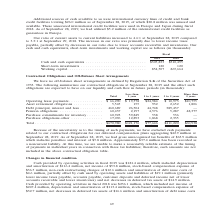According to Coherent's financial document, Where were the unsecured international credit facilities used in? Europe and Japan during fiscal 2018. The document states: "ured international credit facilities were used in Europe and Japan during fiscal 2018. As of September 28, 2019, we had utilized $5.2 million of the i..." Also, What led to the increase in the ratio of current assets to current liabilities? primarily due to lower income taxes payable, partially offset by decreases in our ratio due to lower accounts receivable and inventories.. The document states: "September 29, 2018. The increase in our ratio was primarily due to lower income taxes payable, partially offset by decreases in our ratio due to lower..." Also, In which years was information on cash and cash equivalents, short-term investments and working capital provided? The document shows two values: 2019 and 2018. From the document: "Fiscal 2019 2018 Fiscal 2019 2018..." Additionally, In which year was Cash and cash equivalents larger? According to the financial document, 2018. The relevant text states: "Fiscal 2019 2018..." Also, can you calculate: What was the change in Short-term investments in 2019 from 2018? I cannot find a specific answer to this question in the financial document. Also, can you calculate: What was the percentage change in Short-term investments in 2019 from 2018? I cannot find a specific answer to this question in the financial document. 